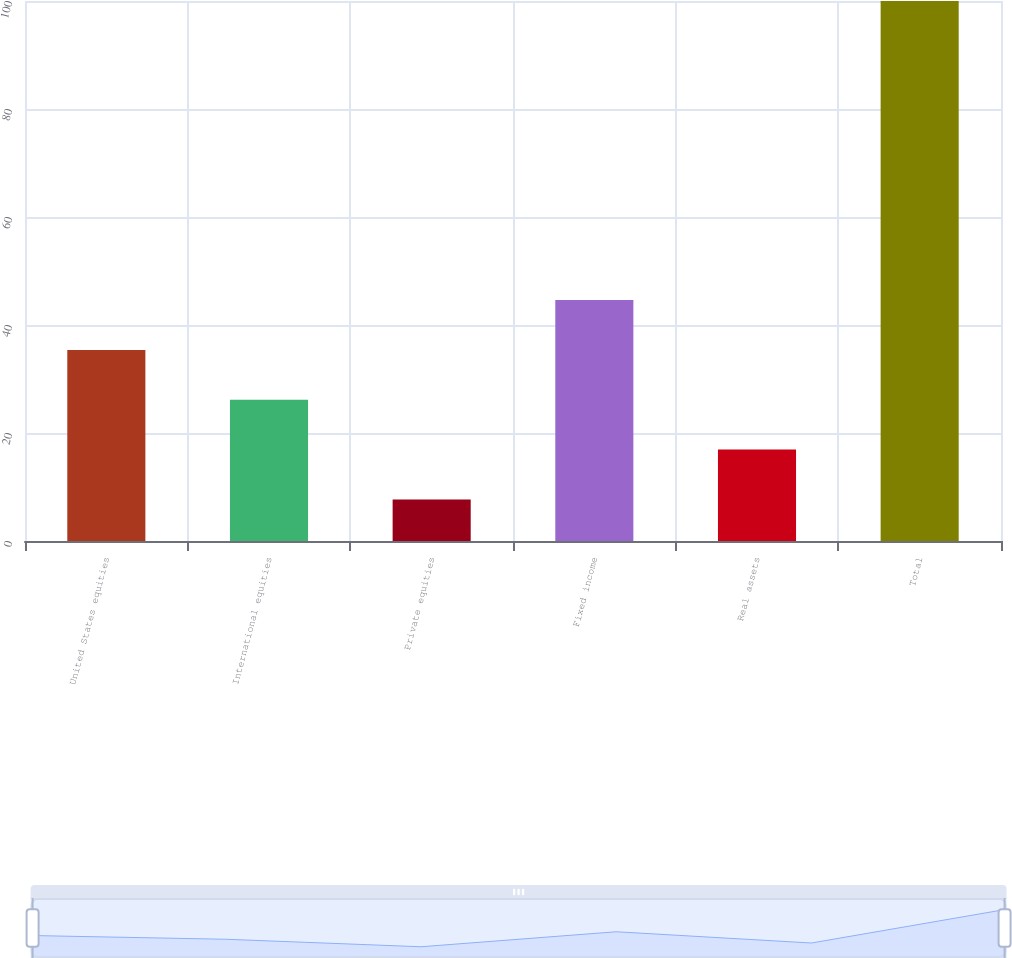Convert chart. <chart><loc_0><loc_0><loc_500><loc_500><bar_chart><fcel>United States equities<fcel>International equities<fcel>Private equities<fcel>Fixed income<fcel>Real assets<fcel>Total<nl><fcel>35.39<fcel>26.16<fcel>7.7<fcel>44.62<fcel>16.93<fcel>100<nl></chart> 